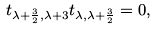<formula> <loc_0><loc_0><loc_500><loc_500>t _ { \lambda + \frac { 3 } { 2 } , \lambda + 3 } t _ { \lambda , \lambda + \frac { 3 } { 2 } } = 0 ,</formula> 